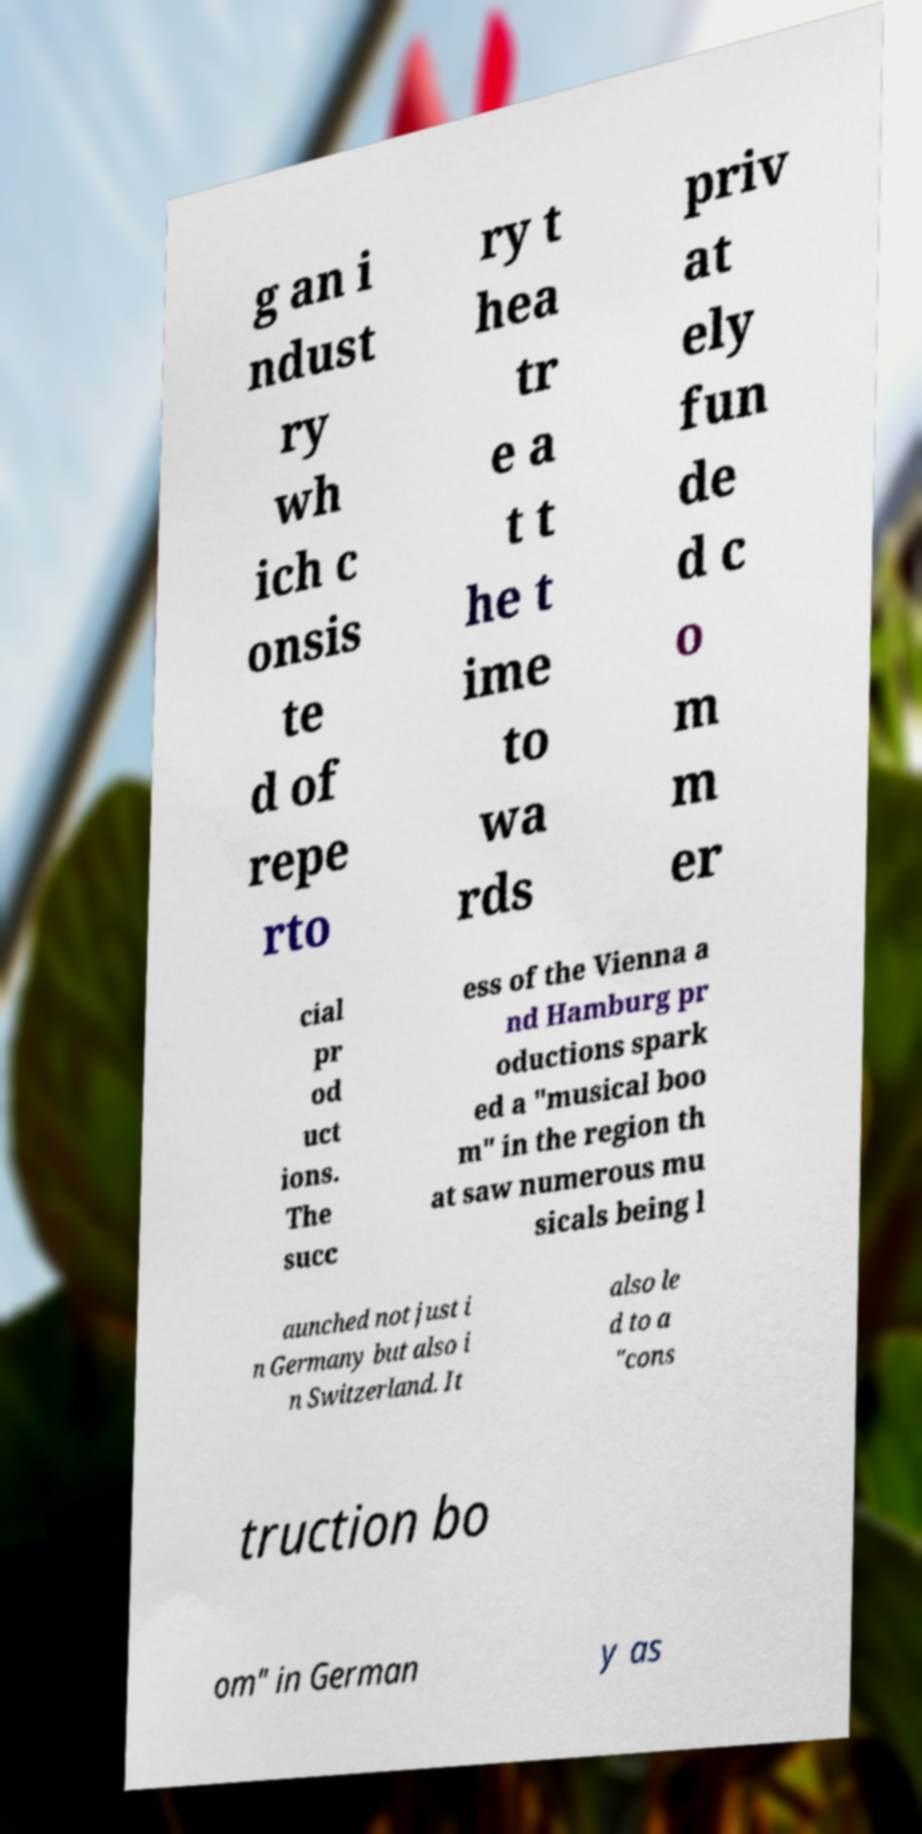What messages or text are displayed in this image? I need them in a readable, typed format. g an i ndust ry wh ich c onsis te d of repe rto ry t hea tr e a t t he t ime to wa rds priv at ely fun de d c o m m er cial pr od uct ions. The succ ess of the Vienna a nd Hamburg pr oductions spark ed a "musical boo m" in the region th at saw numerous mu sicals being l aunched not just i n Germany but also i n Switzerland. It also le d to a "cons truction bo om" in German y as 